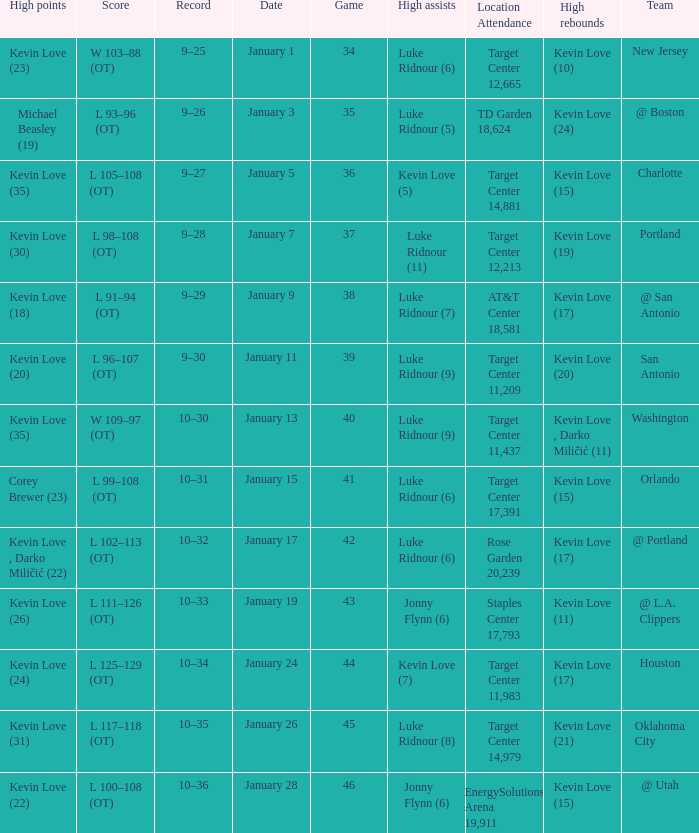What is the highest game with team @ l.a. clippers? 43.0. 